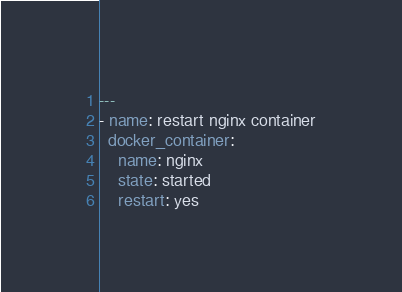<code> <loc_0><loc_0><loc_500><loc_500><_YAML_>---
- name: restart nginx container
  docker_container:
    name: nginx
    state: started
    restart: yes</code> 